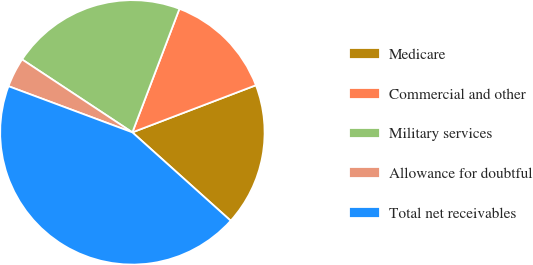Convert chart. <chart><loc_0><loc_0><loc_500><loc_500><pie_chart><fcel>Medicare<fcel>Commercial and other<fcel>Military services<fcel>Allowance for doubtful<fcel>Total net receivables<nl><fcel>17.45%<fcel>13.41%<fcel>21.49%<fcel>3.62%<fcel>44.02%<nl></chart> 